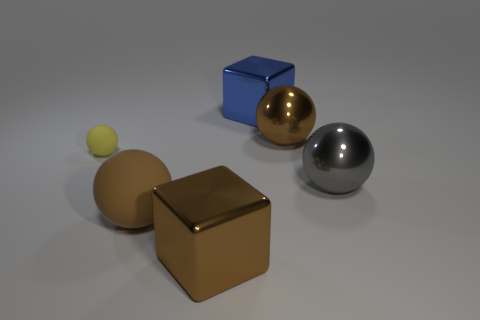How many spheres are either gray objects or rubber objects?
Ensure brevity in your answer.  3. How many shiny things are either big purple objects or yellow spheres?
Keep it short and to the point. 0. There is another rubber object that is the same shape as the brown matte thing; what size is it?
Give a very brief answer. Small. Is there anything else that has the same size as the gray thing?
Give a very brief answer. Yes. Does the yellow matte sphere have the same size as the brown ball right of the big brown metallic cube?
Your answer should be compact. No. There is a matte thing that is right of the yellow rubber ball; what is its shape?
Ensure brevity in your answer.  Sphere. The cube that is in front of the brown sphere to the right of the blue shiny object is what color?
Ensure brevity in your answer.  Brown. The other metal object that is the same shape as the gray metallic thing is what color?
Your answer should be compact. Brown. How many small rubber balls have the same color as the tiny thing?
Your answer should be very brief. 0. Does the small rubber ball have the same color as the metal sphere behind the yellow matte sphere?
Keep it short and to the point. No. 